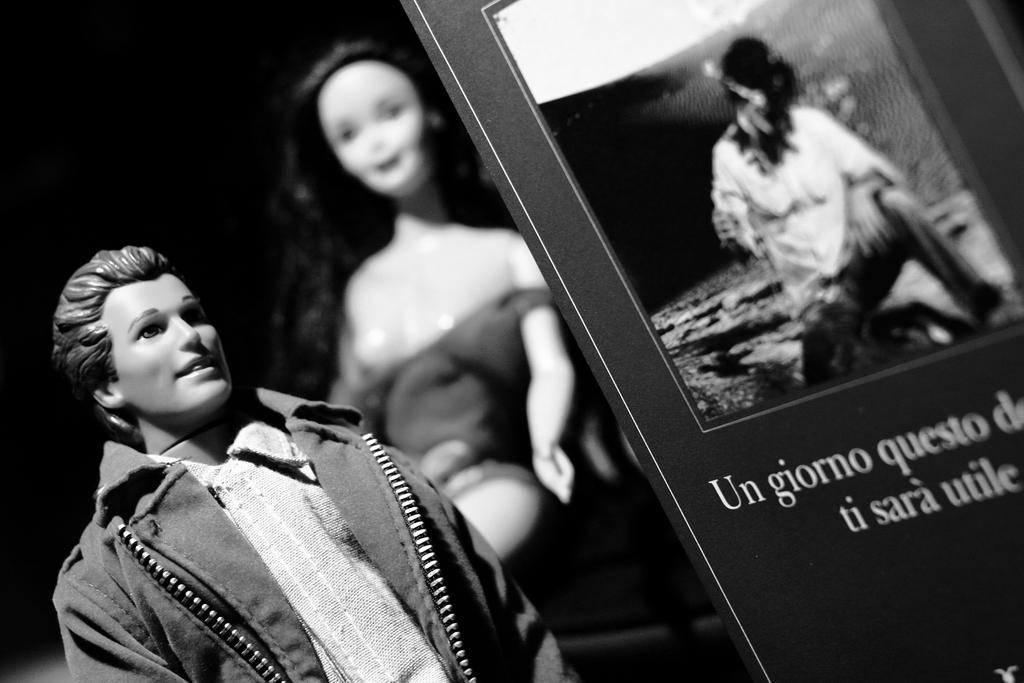Describe this image in one or two sentences. As we can see in the image there are toys and a banner. On banner there is a person and some matter written. 